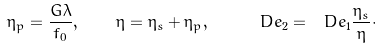Convert formula to latex. <formula><loc_0><loc_0><loc_500><loc_500>\eta _ { p } = \frac { G \lambda } { f _ { 0 } } , \quad \eta = \eta _ { s } + \eta _ { p } , \quad \ D e _ { 2 } = \ D e _ { 1 } \frac { \eta _ { s } } { \eta } \cdot</formula> 